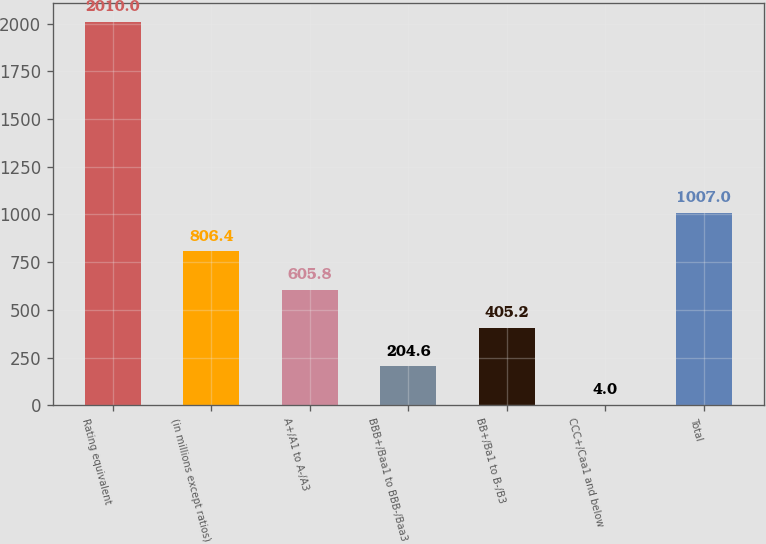Convert chart. <chart><loc_0><loc_0><loc_500><loc_500><bar_chart><fcel>Rating equivalent<fcel>(in millions except ratios)<fcel>A+/A1 to A-/A3<fcel>BBB+/Baa1 to BBB-/Baa3<fcel>BB+/Ba1 to B-/B3<fcel>CCC+/Caa1 and below<fcel>Total<nl><fcel>2010<fcel>806.4<fcel>605.8<fcel>204.6<fcel>405.2<fcel>4<fcel>1007<nl></chart> 